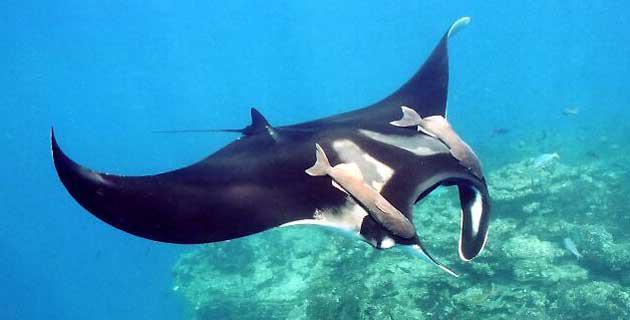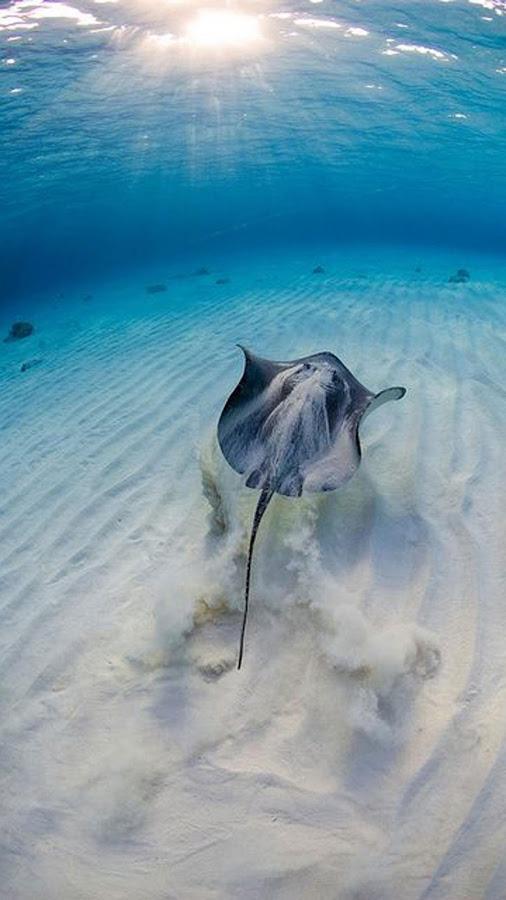The first image is the image on the left, the second image is the image on the right. For the images shown, is this caption "The right image features two rays." true? Answer yes or no. No. The first image is the image on the left, the second image is the image on the right. Analyze the images presented: Is the assertion "a stingray is moving the sandy ocean bottom move while swimming" valid? Answer yes or no. Yes. 